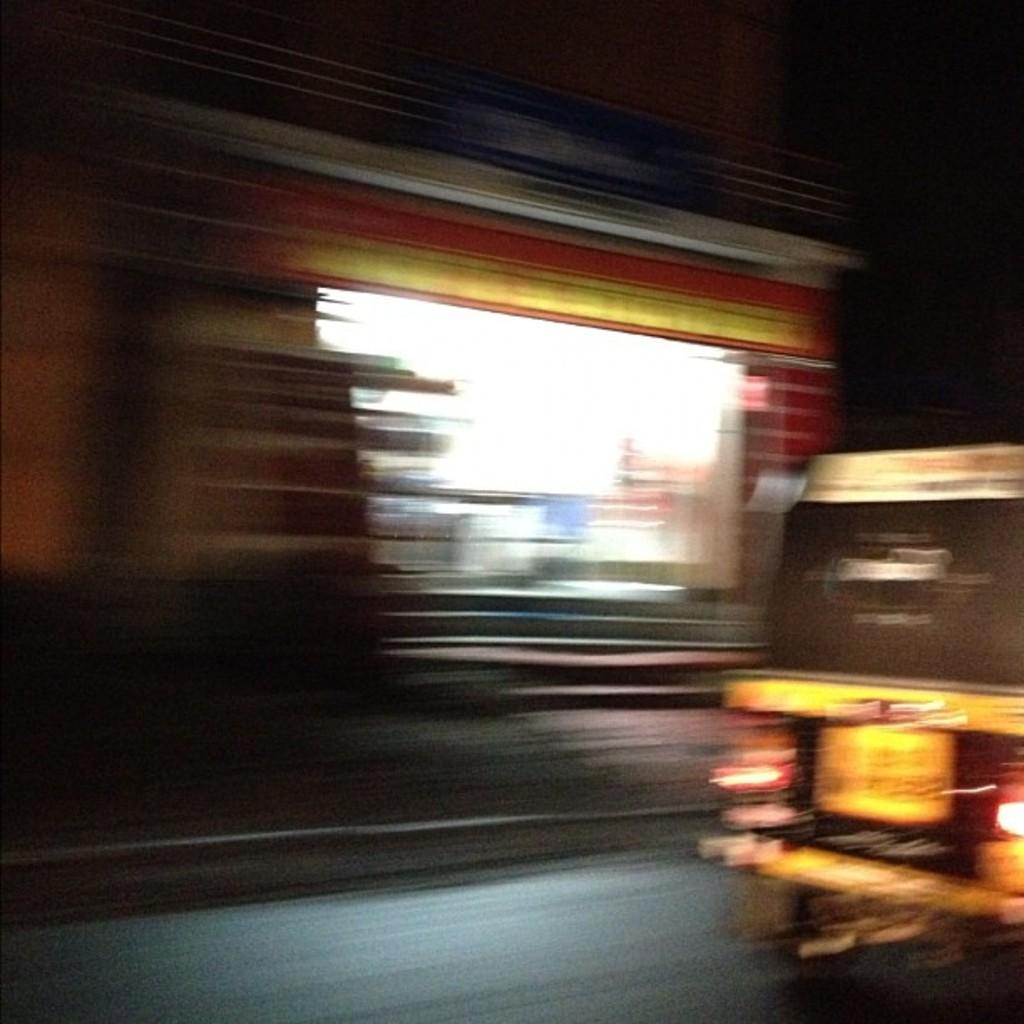How would you summarize this image in a sentence or two? In this picture we can see an auto rickshaw on the right side, in the background there is a building, we can see a blurry background. 